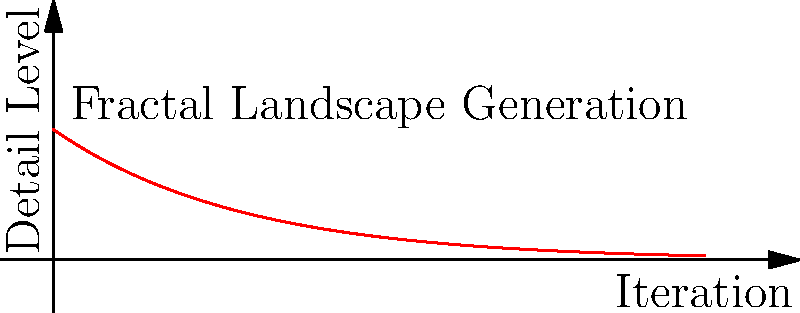In fractal-based procedural landscape generation for virtual film sets, how does the level of detail change as the number of iterations increases? Describe the relationship mathematically and explain its significance for balancing visual complexity and computational resources. 1. Fractal geometry in landscape generation uses self-similar patterns at different scales.

2. The level of detail (LoD) in fractal landscapes typically follows an exponential decay function as iterations increase:

   $$LoD = k \cdot b^n$$

   Where:
   $k$ is a constant
   $b$ is the base (typically 0.5 for halving detail)
   $n$ is the number of iterations

3. In the graph, we see this exponential decay where $k=1$ and $b=0.5$:

   $$LoD = 0.5^n$$

4. As iterations increase, the added detail becomes progressively finer:
   - Iteration 1: $LoD = 0.5^1 = 0.5$
   - Iteration 2: $LoD = 0.5^2 = 0.25$
   - Iteration 3: $LoD = 0.5^3 = 0.125$

5. This relationship is significant because:
   a) It allows for efficient use of computational resources by reducing detail in less important areas.
   b) It provides a natural-looking distribution of features across scales.
   c) It enables the filmmaker to control the balance between visual complexity and render time by adjusting the number of iterations.

6. In practice, filmmakers can use this relationship to:
   - Set a cut-off point for iterations based on the distance from the camera.
   - Allocate more computational resources to foreground elements.
   - Create landscapes that appear detailed from a distance but don't consume excessive memory or processing power.
Answer: Exponential decay: $LoD = k \cdot b^n$, where $b < 1$ 